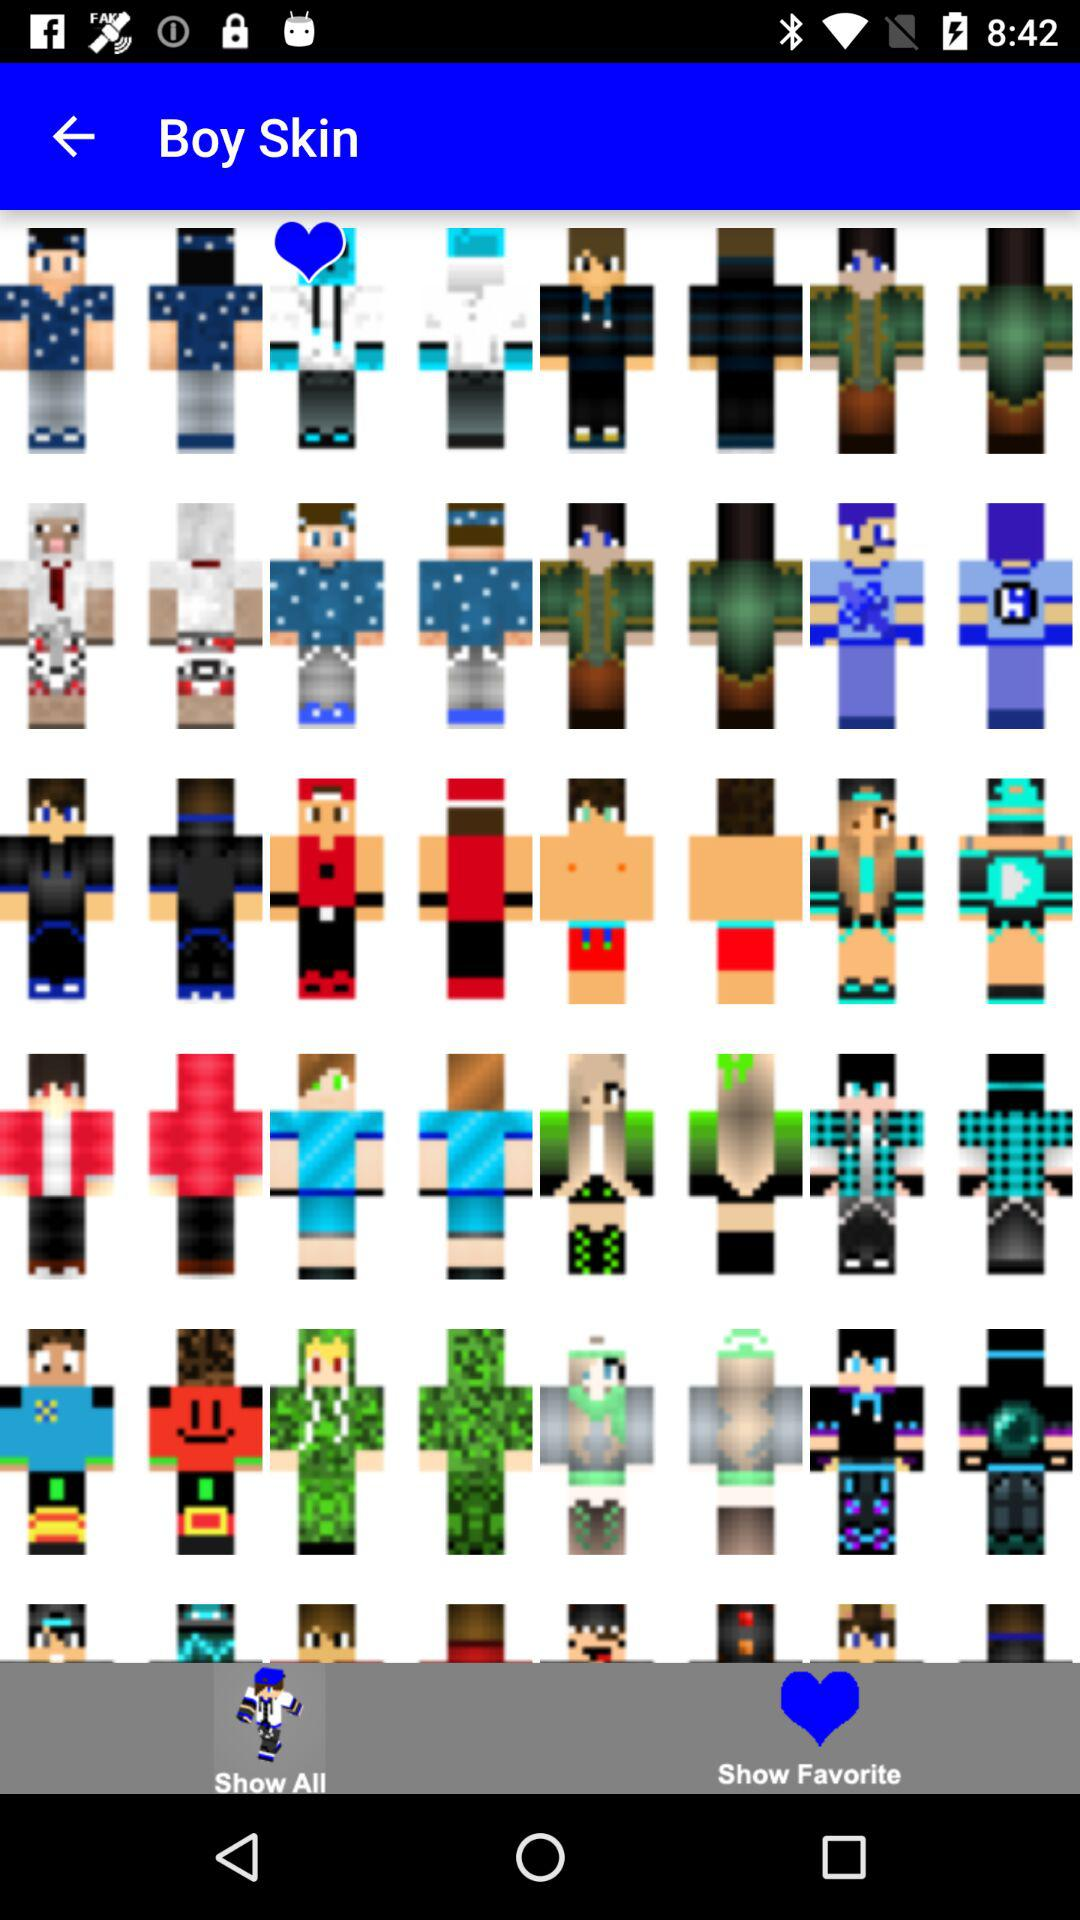Which tab has been selected? The selected tab is "Show All". 